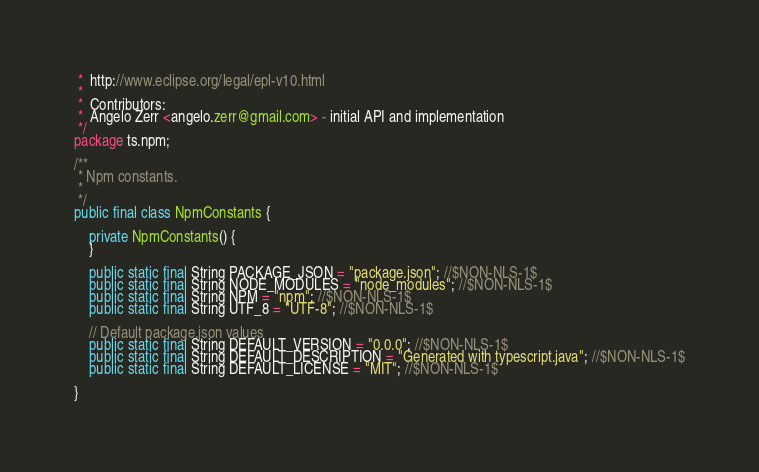<code> <loc_0><loc_0><loc_500><loc_500><_Java_> *  http://www.eclipse.org/legal/epl-v10.html
 *
 *  Contributors:
 *  Angelo Zerr <angelo.zerr@gmail.com> - initial API and implementation
 */
package ts.npm;

/**
 * Npm constants.
 *
 */
public final class NpmConstants {

	private NpmConstants() {
	}

	public static final String PACKAGE_JSON = "package.json"; //$NON-NLS-1$
	public static final String NODE_MODULES = "node_modules"; //$NON-NLS-1$
	public static final String NPM = "npm"; //$NON-NLS-1$
	public static final String UTF_8 = "UTF-8"; //$NON-NLS-1$

	// Default package.json values
	public static final String DEFAULT_VERSION = "0.0.0"; //$NON-NLS-1$
	public static final String DEFAULT_DESCRIPTION = "Generated with typescript.java"; //$NON-NLS-1$
	public static final String DEFAULT_LICENSE = "MIT"; //$NON-NLS-1$

}
</code> 